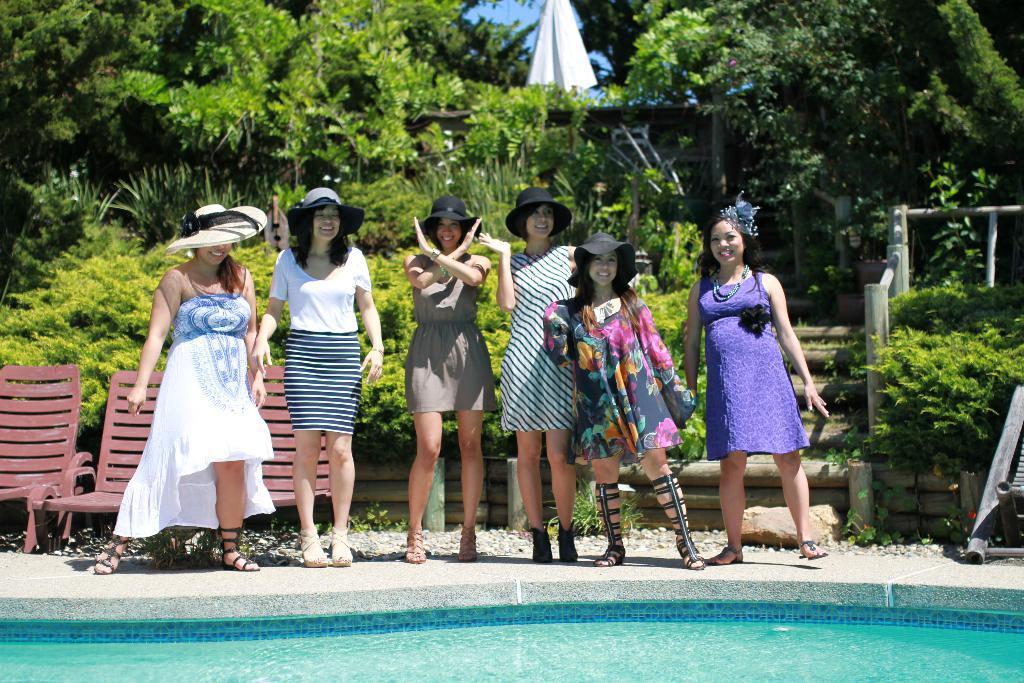In one or two sentences, can you explain what this image depicts? In the image there are group of women standing beside a swimming pool and posing for the photo,some of them are wearing hats and there are three chairs behind the women and in the background there are plenty of trees. 